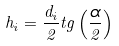<formula> <loc_0><loc_0><loc_500><loc_500>h _ { i } = \frac { d _ { i } } { 2 } t g \left ( \frac { \alpha } { 2 } \right )</formula> 